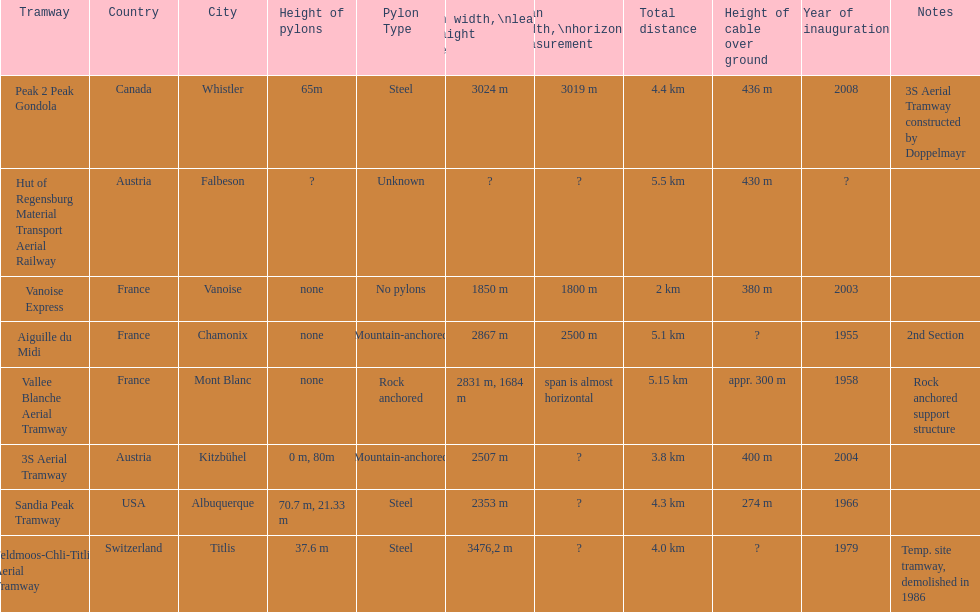Parse the table in full. {'header': ['Tramway', 'Country', 'City', 'Height of pylons', 'Pylon Type', 'Span\xa0width,\\nleaning straight line', 'Span width,\\nhorizontal measurement', 'Total distance', 'Height of cable over ground', 'Year of inauguration', 'Notes'], 'rows': [['Peak 2 Peak Gondola', 'Canada', 'Whistler', '65m', 'Steel', '3024 m', '3019 m', '4.4 km', '436 m', '2008', '3S Aerial Tramway constructed by Doppelmayr'], ['Hut of Regensburg Material Transport Aerial Railway', 'Austria', 'Falbeson', '?', 'Unknown', '?', '?', '5.5 km', '430 m', '?', ''], ['Vanoise Express', 'France', 'Vanoise', 'none', 'No pylons', '1850 m', '1800 m', '2 km', '380 m', '2003', ''], ['Aiguille du Midi', 'France', 'Chamonix', 'none', 'Mountain-anchored', '2867 m', '2500 m', '5.1 km', '?', '1955', '2nd Section'], ['Vallee Blanche Aerial Tramway', 'France', 'Mont Blanc', 'none', 'Rock anchored', '2831 m, 1684 m', 'span is almost horizontal', '5.15 km', 'appr. 300 m', '1958', 'Rock anchored support structure'], ['3S Aerial Tramway', 'Austria', 'Kitzbühel', '0 m, 80m', 'Mountain-anchored', '2507 m', '?', '3.8 km', '400 m', '2004', ''], ['Sandia Peak Tramway', 'USA', 'Albuquerque', '70.7 m, 21.33 m', 'Steel', '2353 m', '?', '4.3 km', '274 m', '1966', ''], ['Feldmoos-Chli-Titlis Aerial Tramway', 'Switzerland', 'Titlis', '37.6 m', 'Steel', '3476,2 m', '?', '4.0 km', '?', '1979', 'Temp. site tramway, demolished in 1986']]} How much longer is the peak 2 peak gondola than the 32 aerial tramway? 517. 